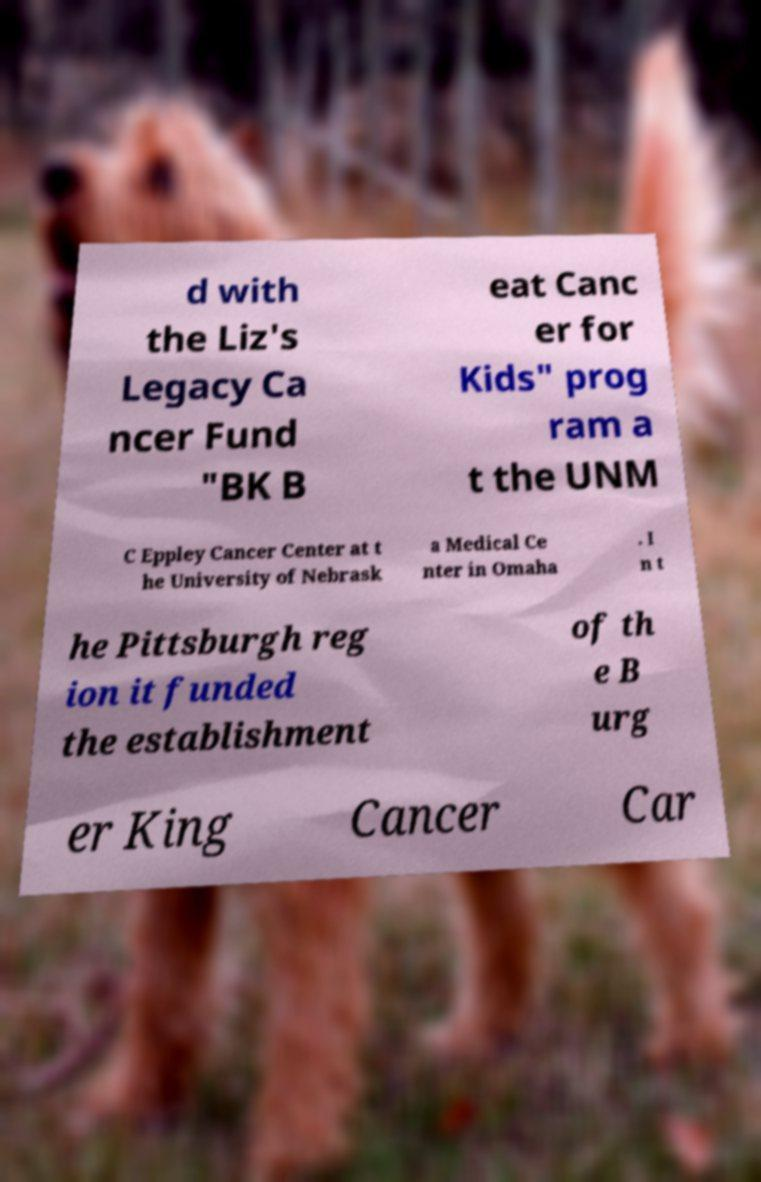Please identify and transcribe the text found in this image. d with the Liz's Legacy Ca ncer Fund "BK B eat Canc er for Kids" prog ram a t the UNM C Eppley Cancer Center at t he University of Nebrask a Medical Ce nter in Omaha . I n t he Pittsburgh reg ion it funded the establishment of th e B urg er King Cancer Car 